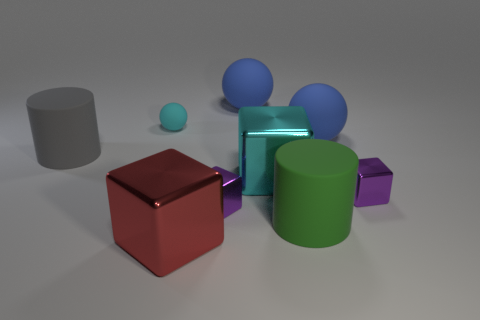There is a gray rubber object; is its shape the same as the big matte object in front of the cyan cube?
Your response must be concise. Yes. The big shiny object that is the same color as the tiny matte object is what shape?
Provide a succinct answer. Cube. Are there fewer big spheres in front of the large green cylinder than gray matte cylinders?
Offer a very short reply. Yes. Do the big gray object and the large green object have the same shape?
Offer a very short reply. Yes. What size is the cyan object that is the same material as the red block?
Give a very brief answer. Large. Are there fewer objects than large matte spheres?
Offer a very short reply. No. How many big things are gray objects or red metallic things?
Your response must be concise. 2. What number of large objects are both behind the tiny matte thing and in front of the gray rubber object?
Your answer should be compact. 0. Is the number of small cyan rubber spheres greater than the number of big brown rubber cylinders?
Offer a terse response. Yes. What number of other things are there of the same shape as the cyan metallic object?
Ensure brevity in your answer.  3. 